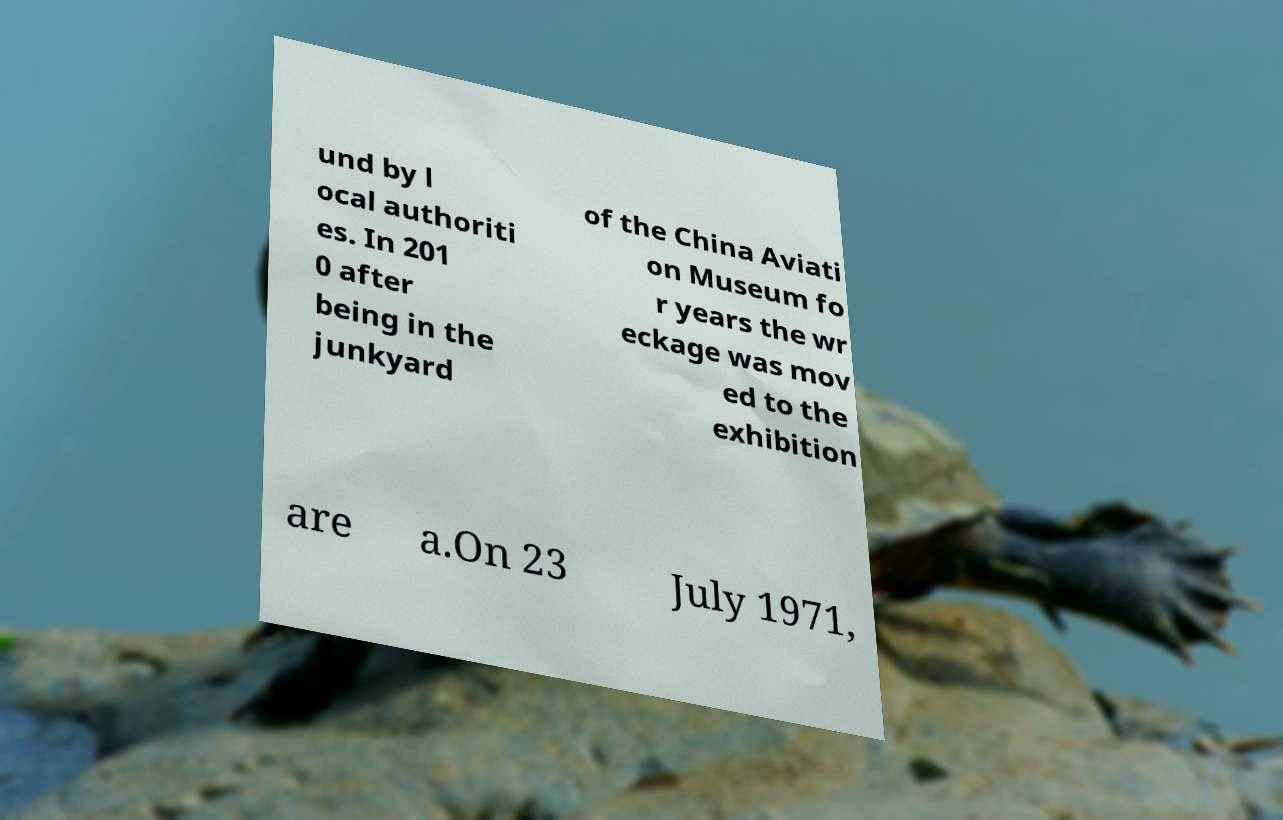Please identify and transcribe the text found in this image. und by l ocal authoriti es. In 201 0 after being in the junkyard of the China Aviati on Museum fo r years the wr eckage was mov ed to the exhibition are a.On 23 July 1971, 